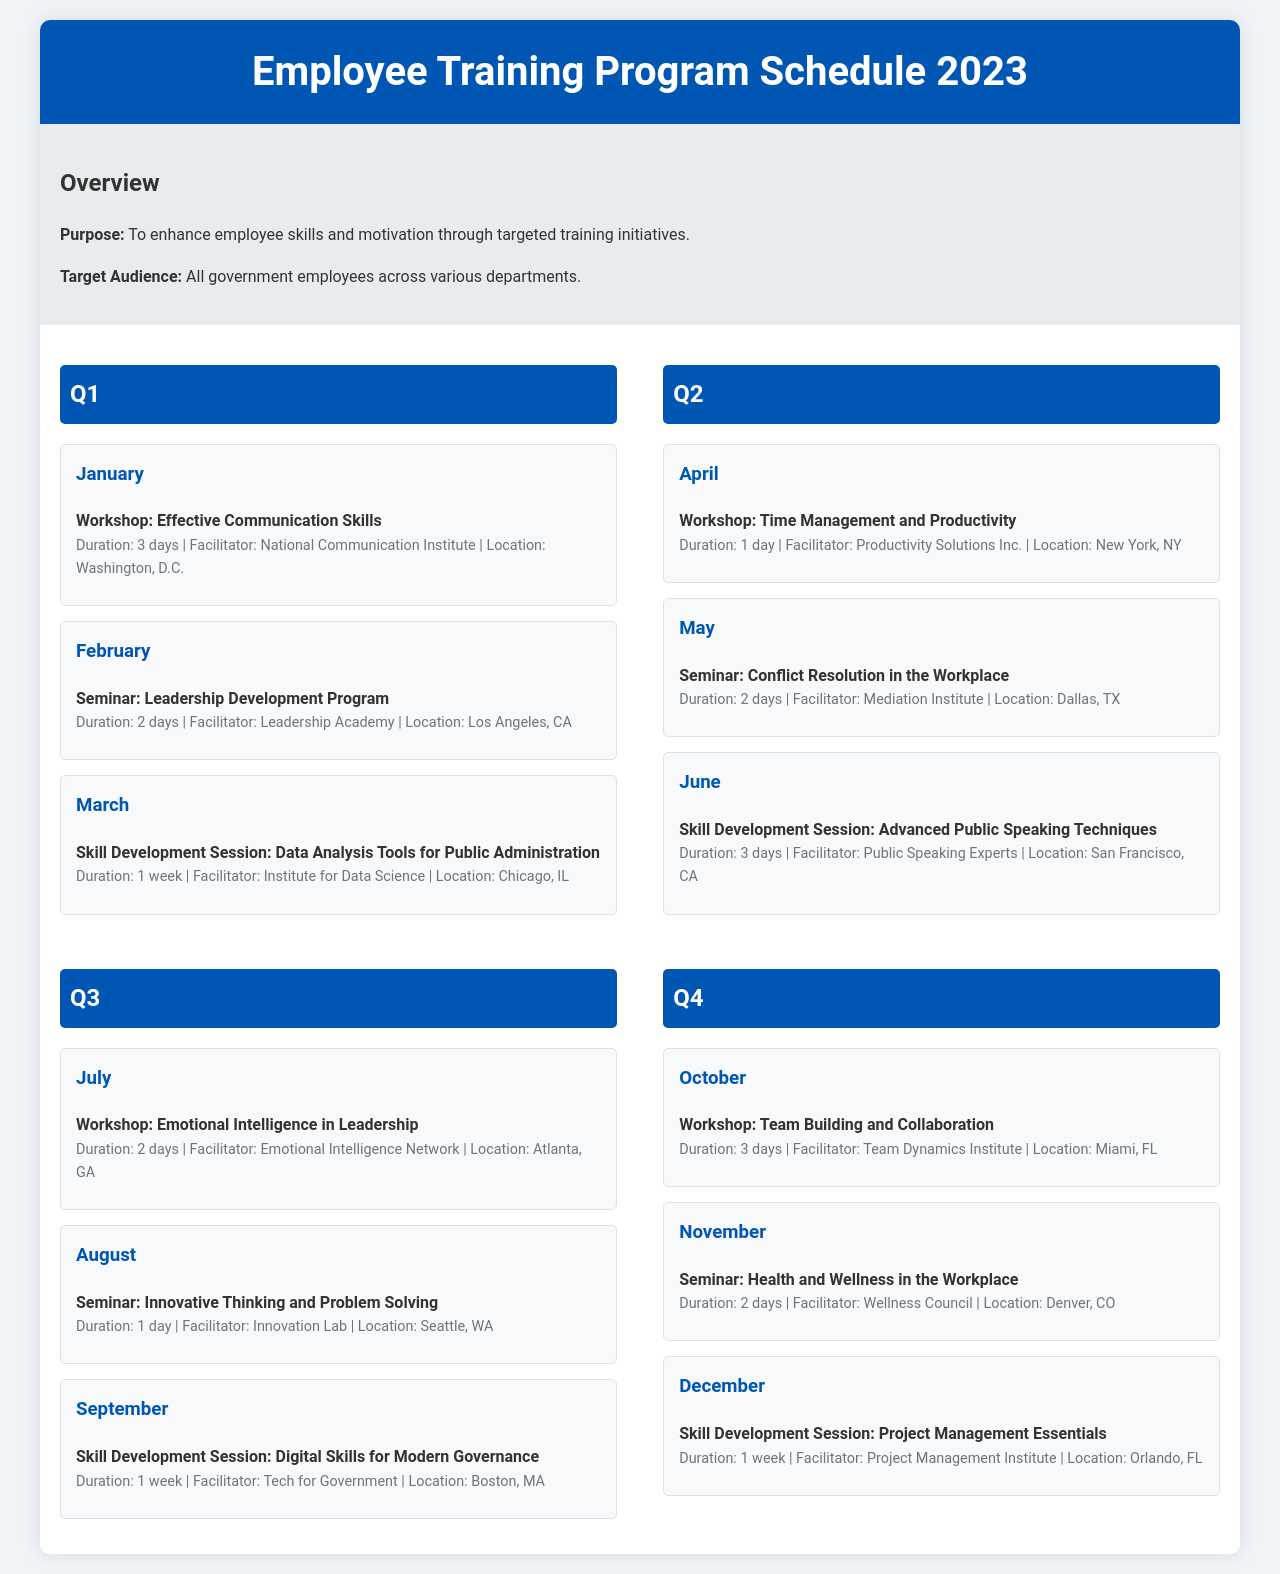What is the title of the document? The title of the document is displayed prominently in the header, indicating the content focus.
Answer: Employee Training Program Schedule 2023 How many skill development sessions are scheduled? The document lists the skill development sessions for each quarter, allowing a count of all sessions.
Answer: 4 Which month features the "Leadership Development Program" seminar? This seminar's scheduling month is mentioned in the timeline section for Q1.
Answer: February What is the duration of the "Effective Communication Skills" workshop? The duration is listed alongside the workshop title in the timeline for January.
Answer: 3 days Where is the "Team Building and Collaboration" workshop held? The location is specified in the details of that particular workshop in the document.
Answer: Miami, FL In what quarter is the "Health and Wellness in the Workplace" seminar scheduled? The quarter hosting the seminar is specified in the timeline.
Answer: Q4 Who facilitates the "Data Analysis Tools for Public Administration" skill development session? The facilitator's name is provided directly in the session details.
Answer: Institute for Data Science What month has the "Digital Skills for Modern Governance" session? This session's month is found in the timeline section detailing Q3.
Answer: September How many days does the "Conflict Resolution in the Workplace" seminar last? The duration is clearly stated in the event details for May.
Answer: 2 days 